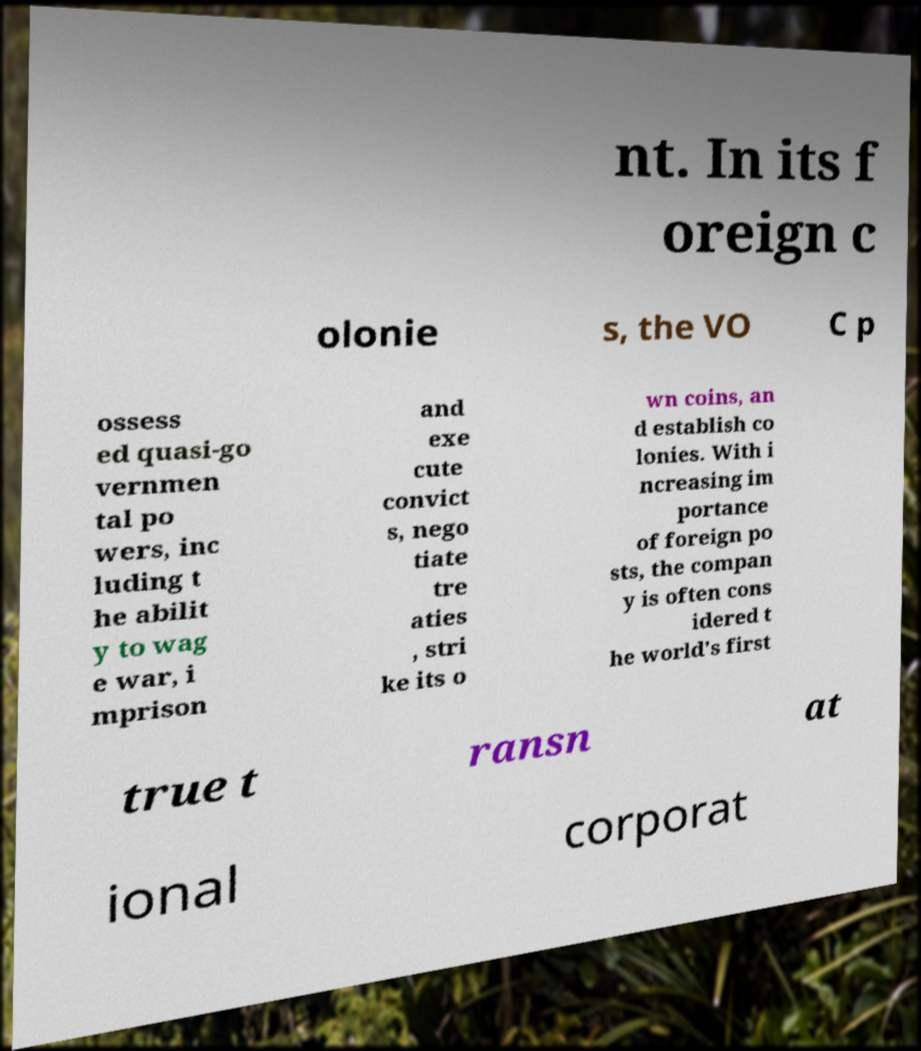Please read and relay the text visible in this image. What does it say? nt. In its f oreign c olonie s, the VO C p ossess ed quasi-go vernmen tal po wers, inc luding t he abilit y to wag e war, i mprison and exe cute convict s, nego tiate tre aties , stri ke its o wn coins, an d establish co lonies. With i ncreasing im portance of foreign po sts, the compan y is often cons idered t he world's first true t ransn at ional corporat 